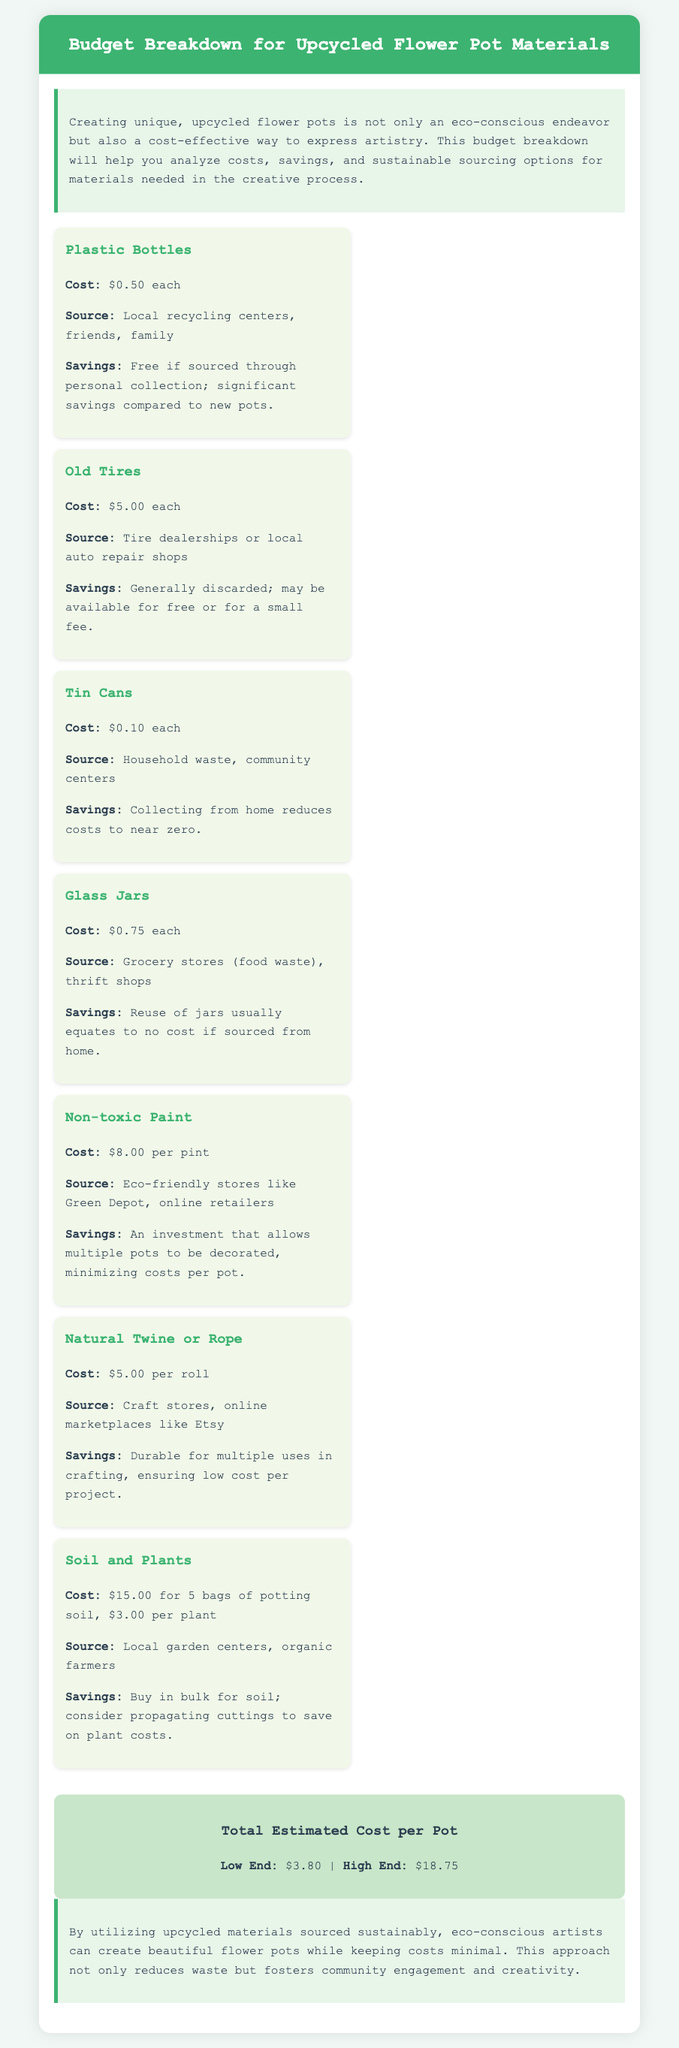What is the cost of plastic bottles? The document states that plastic bottles cost $0.50 each.
Answer: $0.50 Where can old tires be sourced? According to the document, old tires can be sourced from tire dealerships or local auto repair shops.
Answer: Tire dealerships or local auto repair shops What is the total estimated cost per pot on the low end? The low end of the total estimated cost per pot is provided as $3.80.
Answer: $3.80 What materials allow for significant savings when collected from home? The document indicates that plastic bottles, tin cans, and glass jars can be collected from home, which allows for significant savings.
Answer: Plastic bottles, tin cans, and glass jars How much does non-toxic paint cost per pint? The cost of non-toxic paint per pint is mentioned as $8.00.
Answer: $8.00 What is mentioned as a good sourcing option for soil and plants? The document suggests sourcing soil and plants from local garden centers and organic farmers.
Answer: Local garden centers, organic farmers What savings benefit comes from using natural twine or rope? Using natural twine or rope is highlighted as durable for multiple uses, ensuring low cost per project.
Answer: Durable for multiple uses What approach do eco-conscious artists take for sustainability? The document states that eco-conscious artists utilize upcycled materials sourced sustainably.
Answer: Upcycled materials sourced sustainably 